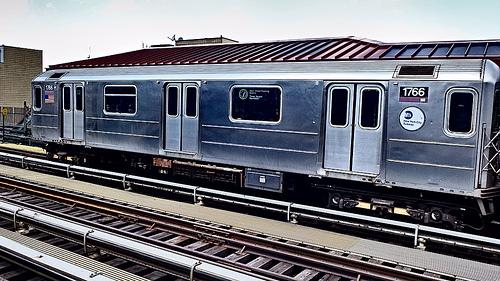Question: what is it on?
Choices:
A. Road.
B. Rail.
C. Path.
D. Rock.
Answer with the letter. Answer: B 